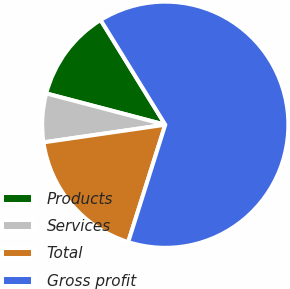<chart> <loc_0><loc_0><loc_500><loc_500><pie_chart><fcel>Products<fcel>Services<fcel>Total<fcel>Gross profit<nl><fcel>12.11%<fcel>6.38%<fcel>17.84%<fcel>63.67%<nl></chart> 